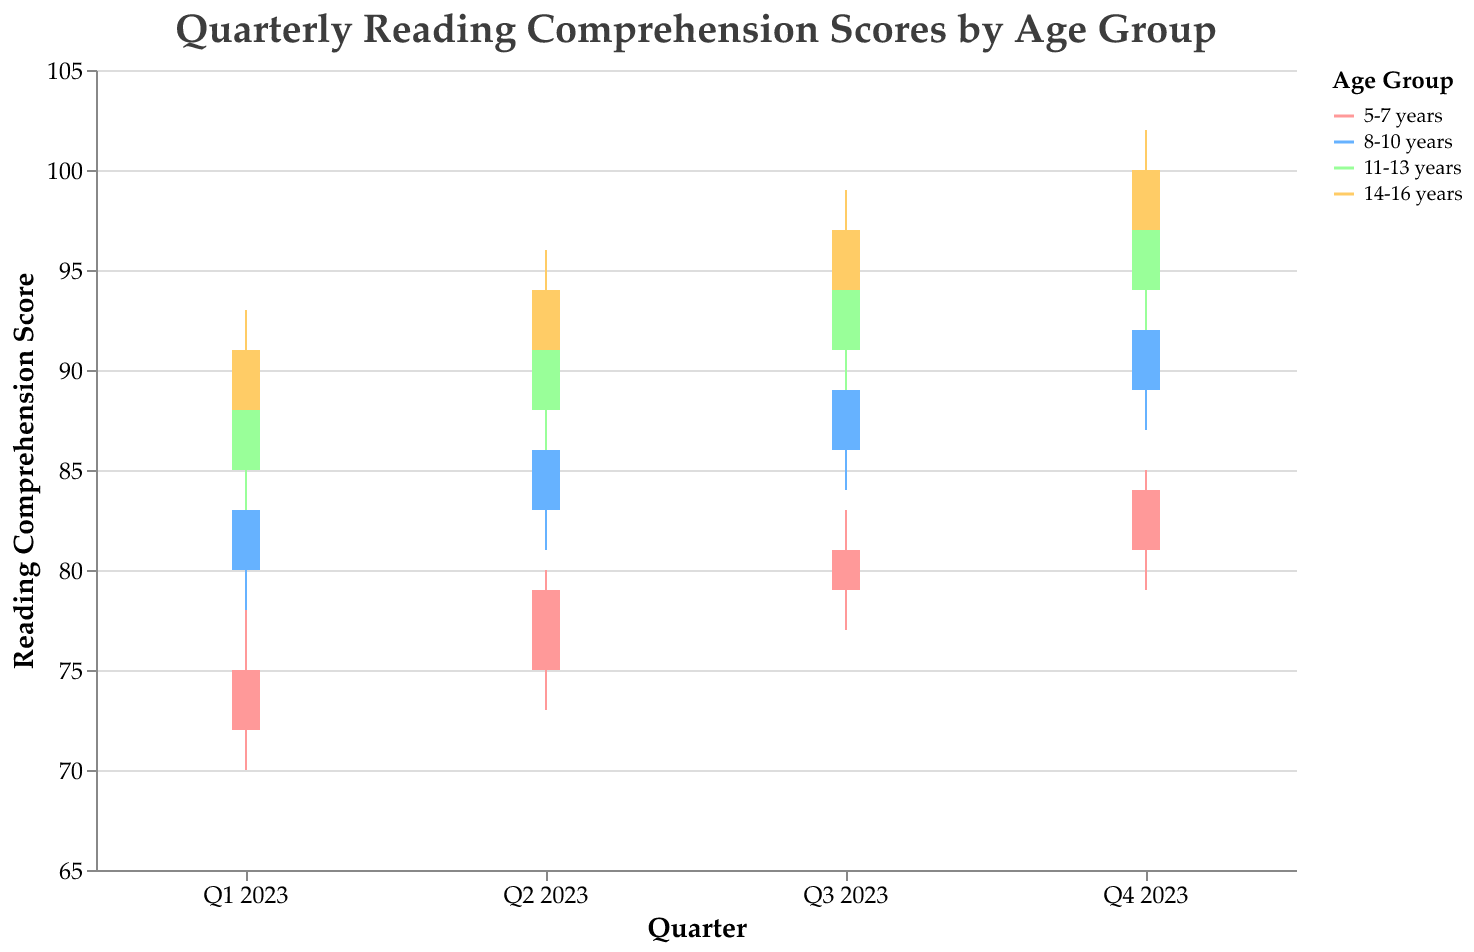What is the highest reading comprehension score for the 5-7 years age group in Q3 2023? The highest reading comprehension score for any age group in any quarter can be determined by looking at the "High" value for that specific age group and quarter. For 5-7 years in Q3 2023, the "High" value is 83.
Answer: 83 What is the average of the closing scores for the 11-13 years age group throughout 2023? To find the average, add up all the closing scores for the 11-13 years age group and divide by the number of quarters. The closing scores are 88, 91, 94, and 97. So, (88 + 91 + 94 + 97) / 4 = 370 / 4 = 92.5
Answer: 92.5 Which age group had the largest high score in Q4 2023? Compare the "High" values for all age groups in Q4 2023. The values are 85 (5-7 years), 94 (8-10 years), 99 (11-13 years), and 102 (14-16 years). The largest is 102 from the 14-16 years age group.
Answer: 14-16 years Did the 8-10 years age group score higher in Q2 2023 or Q3 2023, based on the closing scores? Compare the "Close" values for the 8-10 years age group in Q2 2023 and Q3 2023. The closing scores are 86 in Q2 2023 and 89 in Q3 2023. 89 is higher than 86.
Answer: Q3 2023 What's the difference between the highest and lowest reading comprehension scores for the 14-16 years age group in Q4 2023? Subtract the "Low" value from the "High" value for the 14-16 years age group in Q4 2023. The high is 102 and the low is 95, so 102 - 95 = 7.
Answer: 7 Identify the quarter in 2023 where the 8-10 years age group had the smallest range between their high and low reading comprehension scores. Calculate the range (High - Low) for each quarter for the 8-10 years age group. Q1: 85-78=7, Q2: 88-81=7, Q3: 91-84=7, Q4: 94-87=7. All quarters have the same range of 7.
Answer: All quarters What is the upward trend in closing scores for the 5-7 years age group from Q1 to Q4 2023? Identify the closing scores for the 5-7 years age group and note their sequence across the quarters. The closing scores are 75, 79, 81, 84, showing a steady increase each quarter.
Answer: 75 → 79 → 81 → 84 Which age group shows the most significant growth in the closing scores from Q1 2023 to Q4 2023? Calculate the difference between Q4 and Q1 closing scores for each age group. 5-7 years: 84-75=9, 8-10 years: 92-83=9, 11-13 years: 97-88=9, 14-16 years: 100-91=9. All age groups show the same growth of 9.
Answer: All age groups In which quarter did the 11-13 years age group have the highest opening score in 2023? Compare the "Open" values for the 11-13 years age group across all quarters. The opening scores are 85 (Q1), 88 (Q2), 91 (Q3), and 94 (Q4). The highest is 94 in Q4 2023.
Answer: Q4 2023 